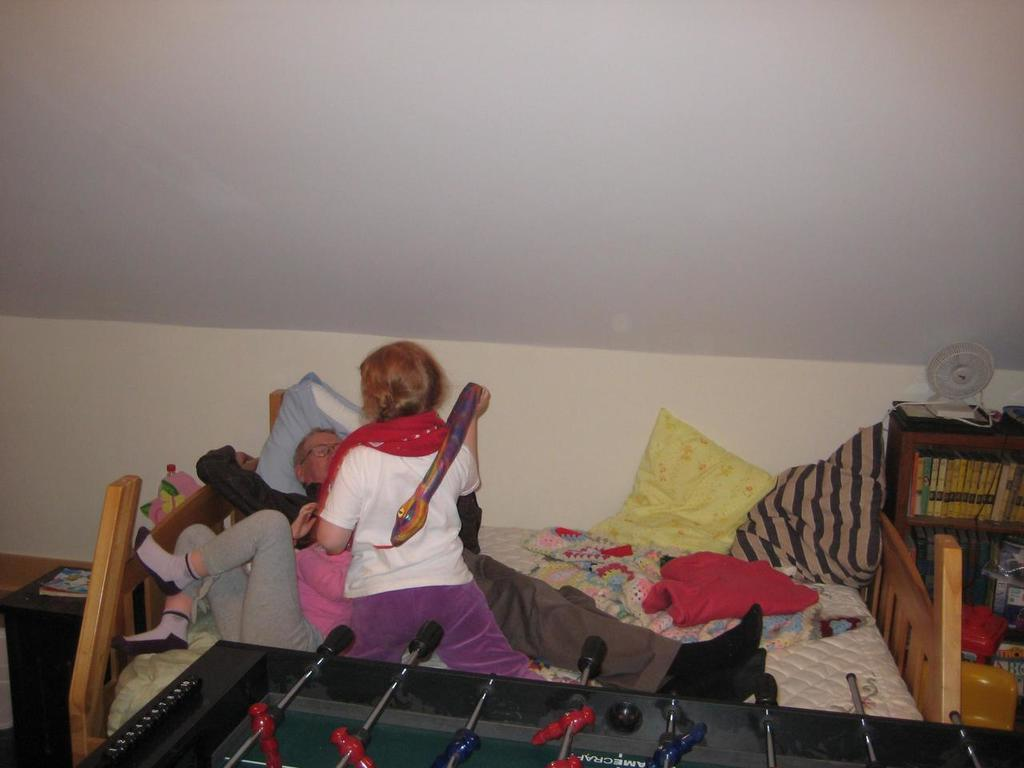What is happening in the center of the image? There are persons lying on the bed in the center of the image. What is in front of the bed? There is a table in front of the bed. What can be seen in the background of the image? There is a wall, a table fan, a rack, books, a pillow, a blanket, and another table in the background of the image. How many beans are visible on the persons' toes in the image? There are no beans or references to toes in the image. 